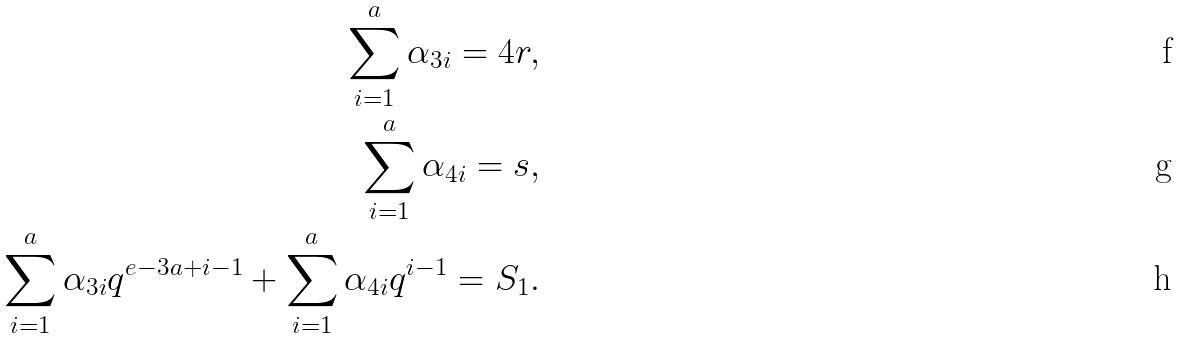Convert formula to latex. <formula><loc_0><loc_0><loc_500><loc_500>\sum _ { i = 1 } ^ { a } \alpha _ { 3 i } = 4 r , \\ \sum _ { i = 1 } ^ { a } \alpha _ { 4 i } = s , \\ \sum _ { i = 1 } ^ { a } \alpha _ { 3 i } q ^ { e - 3 a + i - 1 } + \sum _ { i = 1 } ^ { a } \alpha _ { 4 i } q ^ { i - 1 } = S _ { 1 } .</formula> 